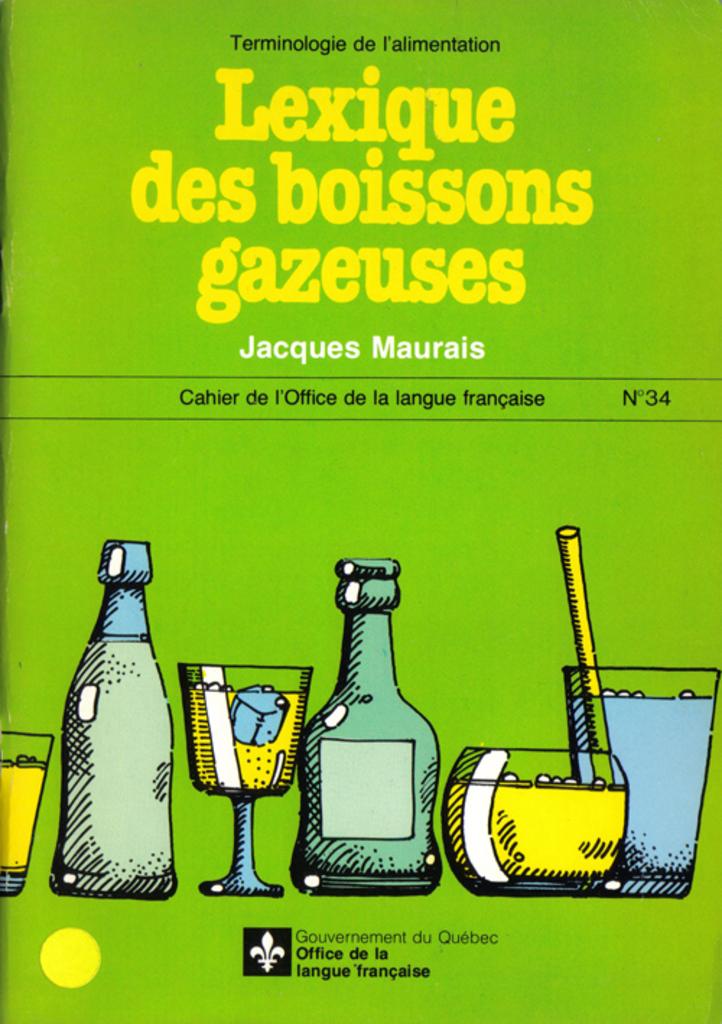Who is the author of this book?
Ensure brevity in your answer.  Jacques maurais. Who published this book?
Offer a terse response. Jacques maurais. 